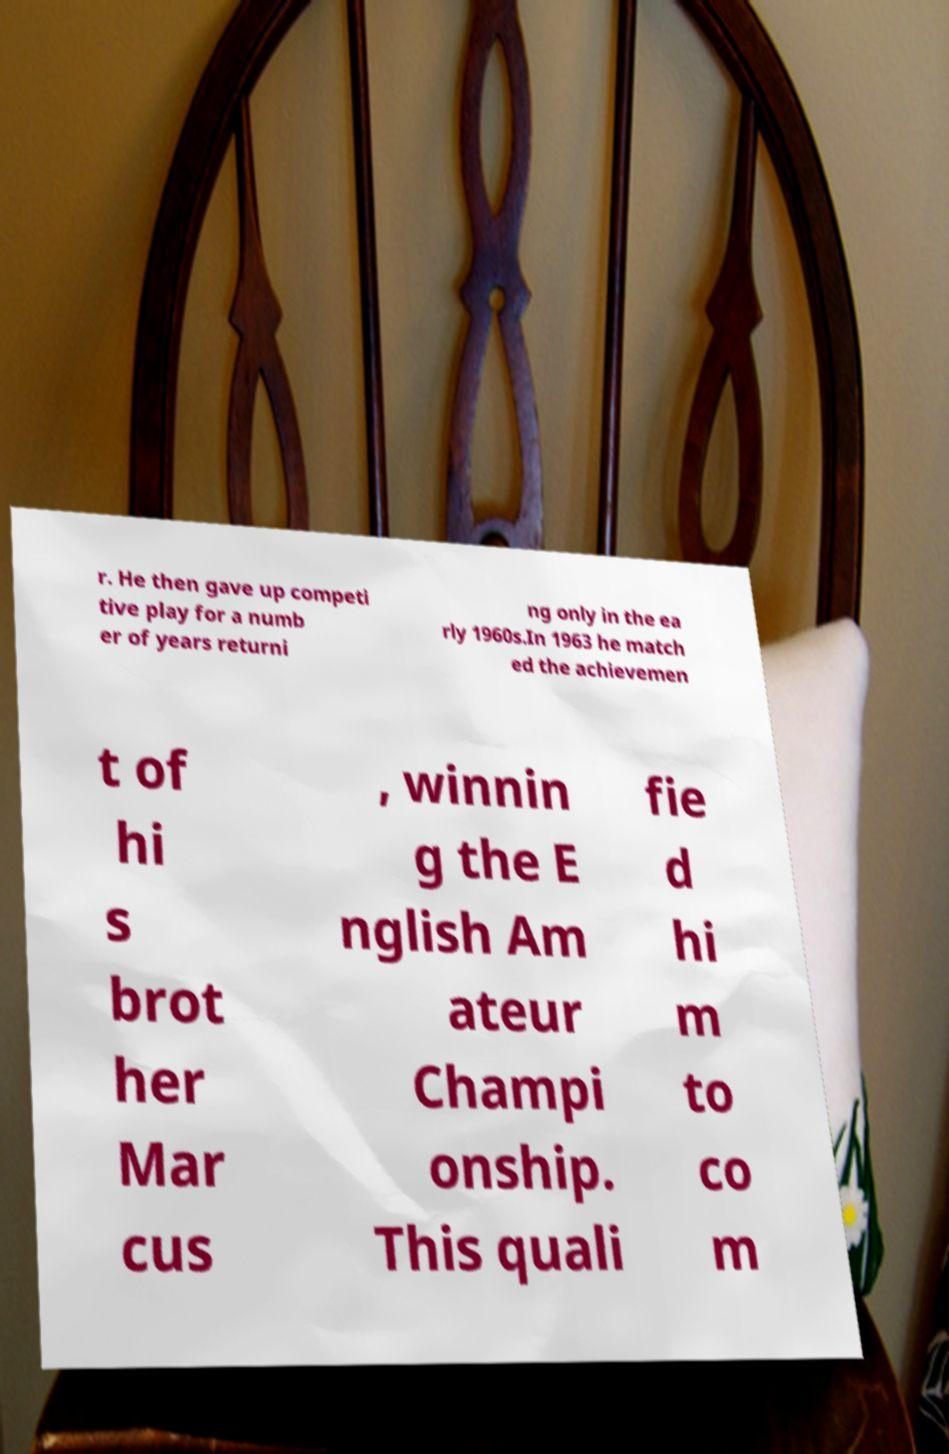There's text embedded in this image that I need extracted. Can you transcribe it verbatim? r. He then gave up competi tive play for a numb er of years returni ng only in the ea rly 1960s.In 1963 he match ed the achievemen t of hi s brot her Mar cus , winnin g the E nglish Am ateur Champi onship. This quali fie d hi m to co m 